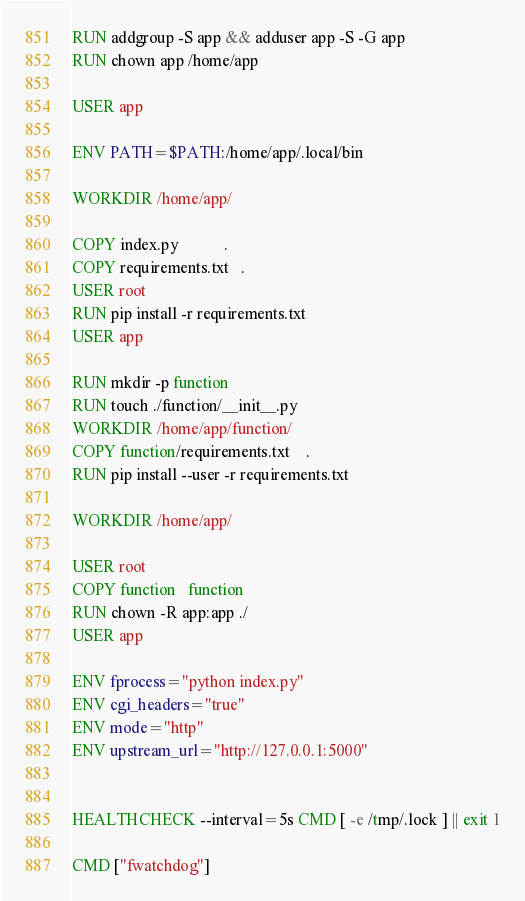Convert code to text. <code><loc_0><loc_0><loc_500><loc_500><_Dockerfile_>RUN addgroup -S app && adduser app -S -G app
RUN chown app /home/app

USER app

ENV PATH=$PATH:/home/app/.local/bin

WORKDIR /home/app/

COPY index.py           .
COPY requirements.txt   .
USER root
RUN pip install -r requirements.txt
USER app

RUN mkdir -p function
RUN touch ./function/__init__.py
WORKDIR /home/app/function/
COPY function/requirements.txt	.
RUN pip install --user -r requirements.txt

WORKDIR /home/app/

USER root
COPY function   function
RUN chown -R app:app ./
USER app

ENV fprocess="python index.py"
ENV cgi_headers="true"
ENV mode="http"
ENV upstream_url="http://127.0.0.1:5000"


HEALTHCHECK --interval=5s CMD [ -e /tmp/.lock ] || exit 1

CMD ["fwatchdog"]
</code> 